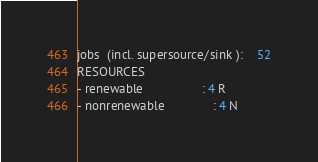<code> <loc_0><loc_0><loc_500><loc_500><_ObjectiveC_>jobs  (incl. supersource/sink ):	52
RESOURCES
- renewable                 : 4 R
- nonrenewable              : 4 N</code> 